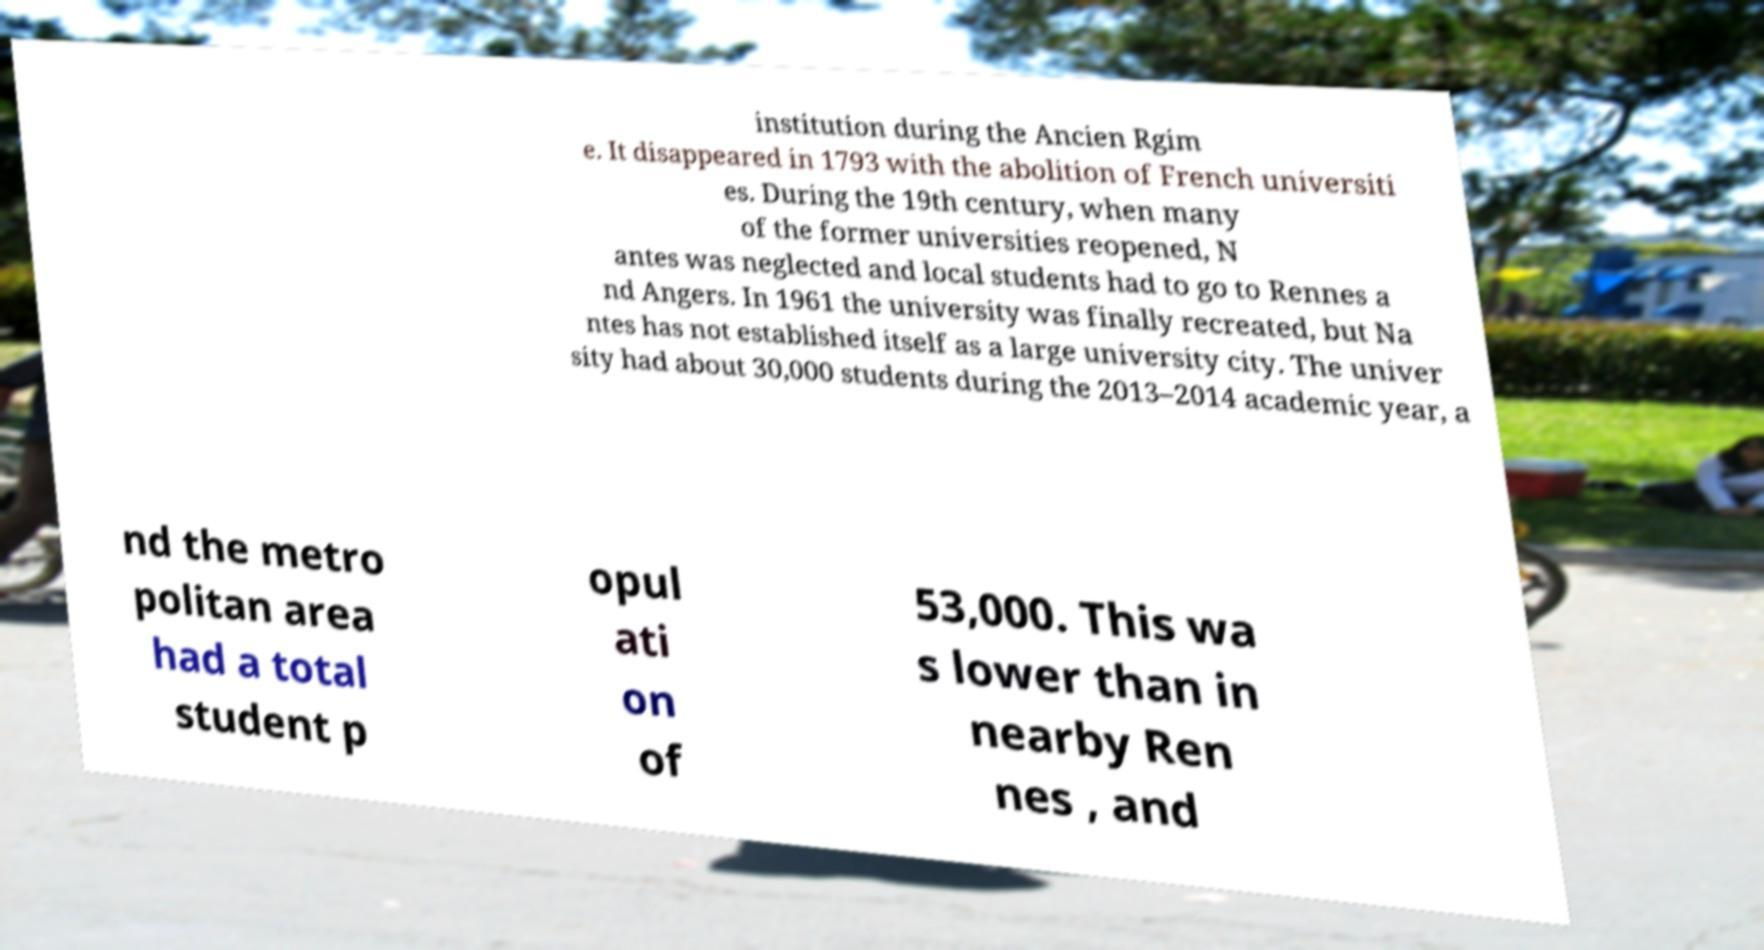Please identify and transcribe the text found in this image. institution during the Ancien Rgim e. It disappeared in 1793 with the abolition of French universiti es. During the 19th century, when many of the former universities reopened, N antes was neglected and local students had to go to Rennes a nd Angers. In 1961 the university was finally recreated, but Na ntes has not established itself as a large university city. The univer sity had about 30,000 students during the 2013–2014 academic year, a nd the metro politan area had a total student p opul ati on of 53,000. This wa s lower than in nearby Ren nes , and 